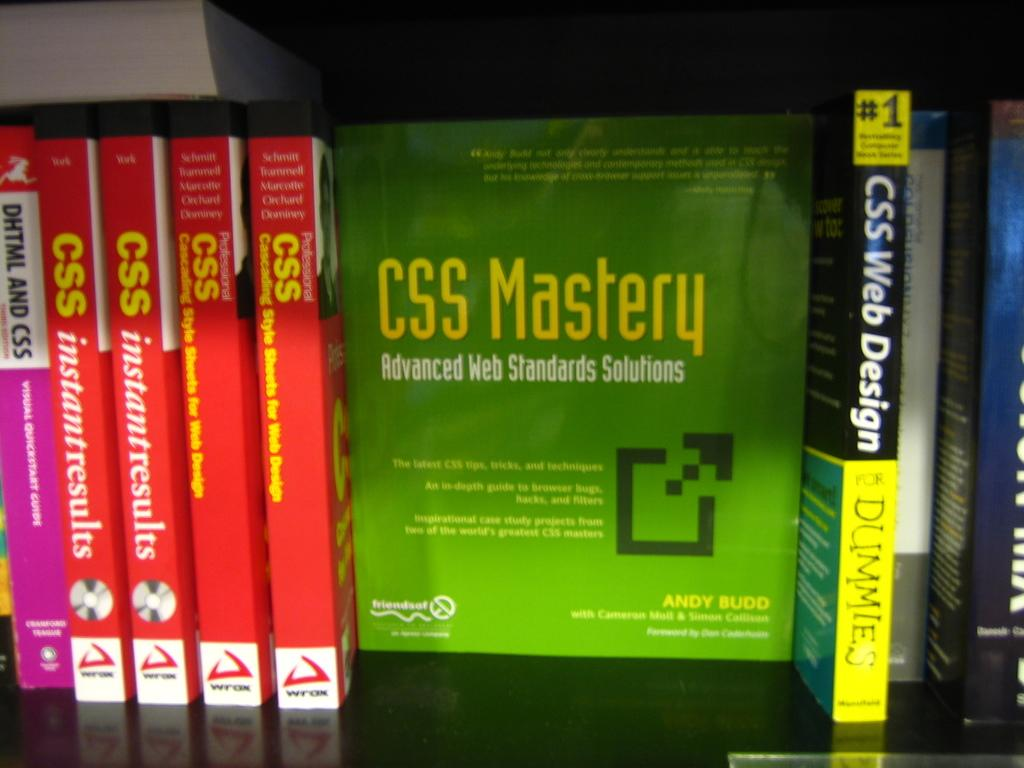<image>
Share a concise interpretation of the image provided. A shelf with a row of green and red books that say CSS Mastery. 